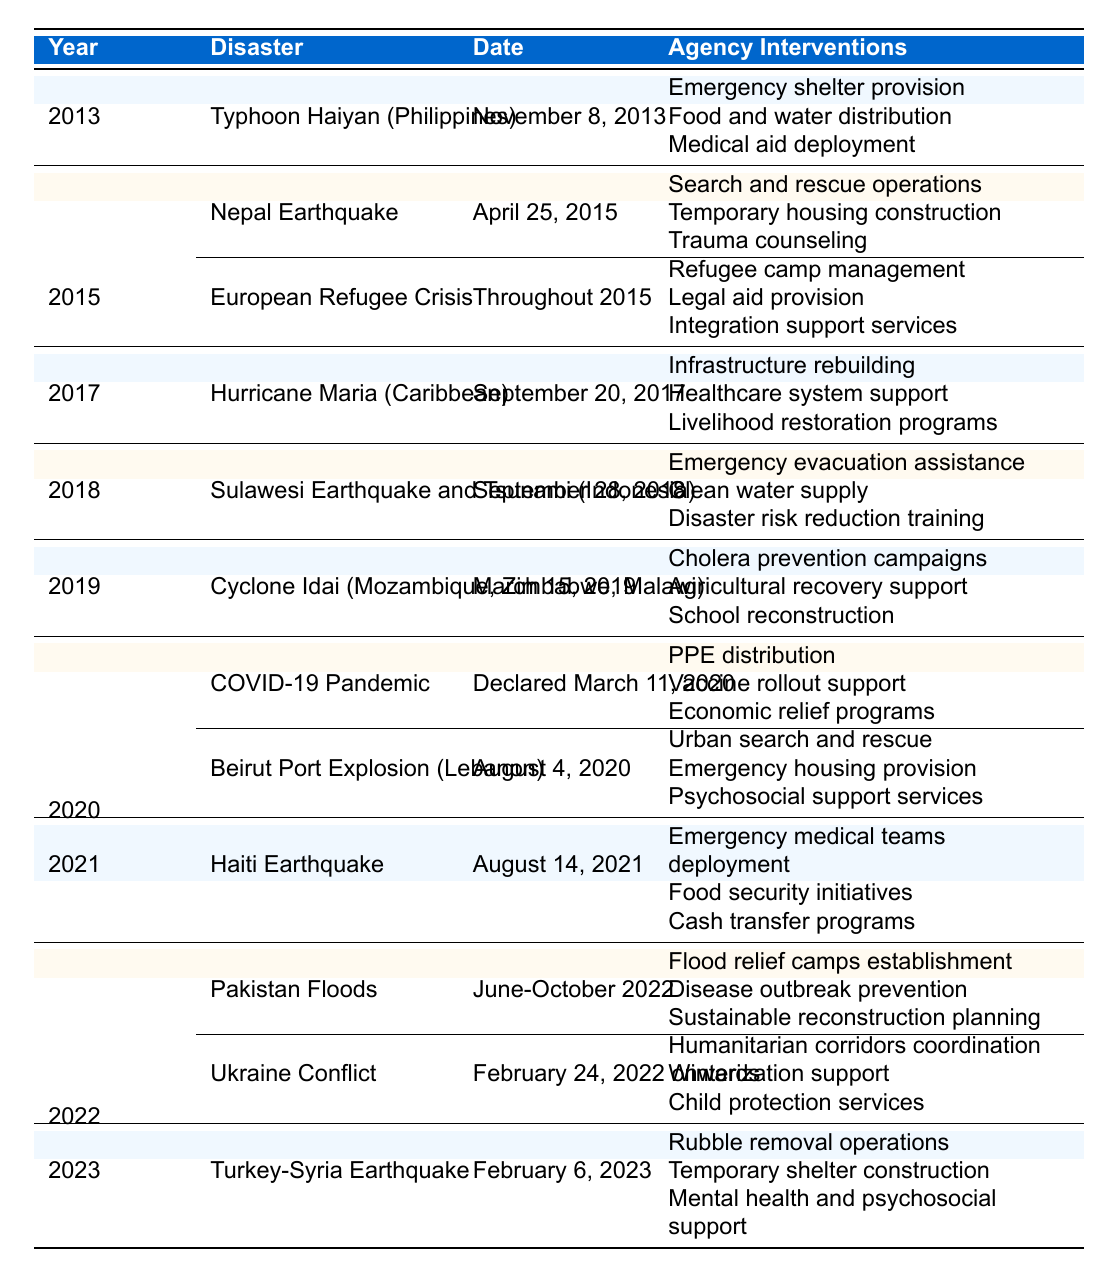What disaster occurred in 2015 that involved search and rescue operations? The table indicates that in 2015, the Nepal Earthquake included agency interventions such as search and rescue operations.
Answer: Nepal Earthquake How many different agency interventions were provided for Typhoon Haiyan? The interventions listed for Typhoon Haiyan include three distinct actions: emergency shelter provision, food and water distribution, and medical aid deployment.
Answer: 3 Was there any agency intervention related to the COVID-19 pandemic in 2020? Yes, the table shows that for the COVID-19 pandemic, interventions included PPE distribution, vaccine rollout support, and economic relief programs.
Answer: Yes Which disaster had the longest duration of agency intervention? The Ukraine Conflict began on February 24, 2022, and continues beyond the table's end date, with multiple interventions listed. This indicates it is ongoing for more than a year.
Answer: Ukraine Conflict In which year did the most disasters occur as listed in the table? In 2015, there were two disasters recorded: the Nepal Earthquake and the European Refugee Crisis, making it the year with the most disasters documented.
Answer: 2015 What type of support was provided for the Turkey-Syria Earthquake? The interventions for the Turkey-Syria Earthquake included rubble removal operations, temporary shelter construction, and mental health and psychosocial support.
Answer: Rubble removal, shelter construction, mental support How many agency interventions were listed in total for the Pakistan Floods and Ukraine Conflict combined? The Pakistan Floods had three interventions, while the Ukraine Conflict also had three interventions, totaling six.
Answer: 6 Did any of the disasters listed involve trauma counseling as an agency intervention? Yes, the Nepal Earthquake included trauma counseling as one of its interventions.
Answer: Yes What was one specific type of intervention provided in response to Hurricane Maria? One specific type of intervention for Hurricane Maria was infrastructure rebuilding, in addition to healthcare system support and livelihood restoration programs.
Answer: Infrastructure rebuilding Which disaster led to the provision of cash transfer programs? The Haiti Earthquake in 2021 included cash transfer programs as one of its interventions among others like emergency medical teams and food security initiatives.
Answer: Haiti Earthquake How does the number of agency interventions for the 2020 disasters compare to those in 2021? In 2020, there were a total of six interventions (three for COVID-19 and three for the Beirut Port Explosion), while in 2021, there were three interventions for the Haiti Earthquake. Therefore, 2020 had more interventions than 2021.
Answer: 2020 had more interventions than 2021 